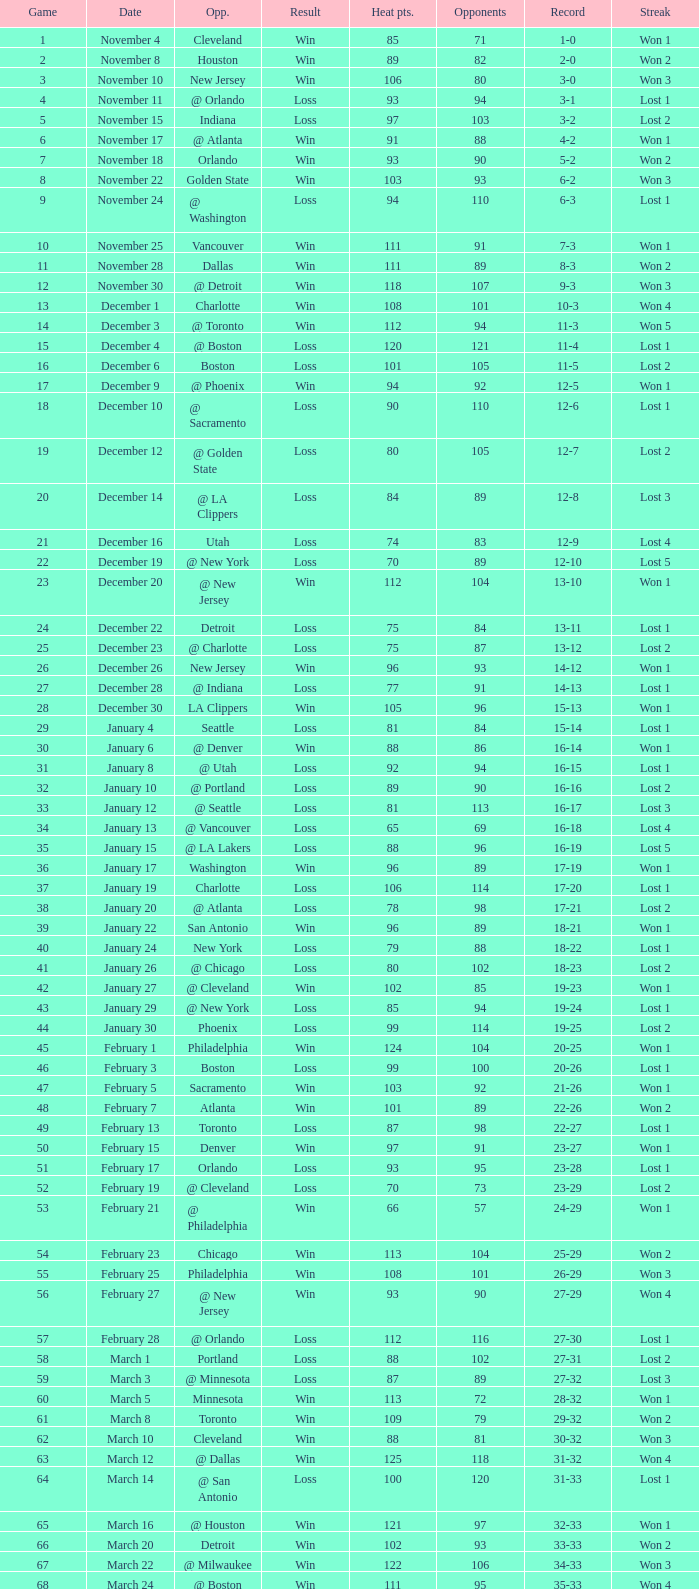What is the average Heat Points, when Result is "Loss", when Game is greater than 72, and when Date is "April 21"? 92.0. 